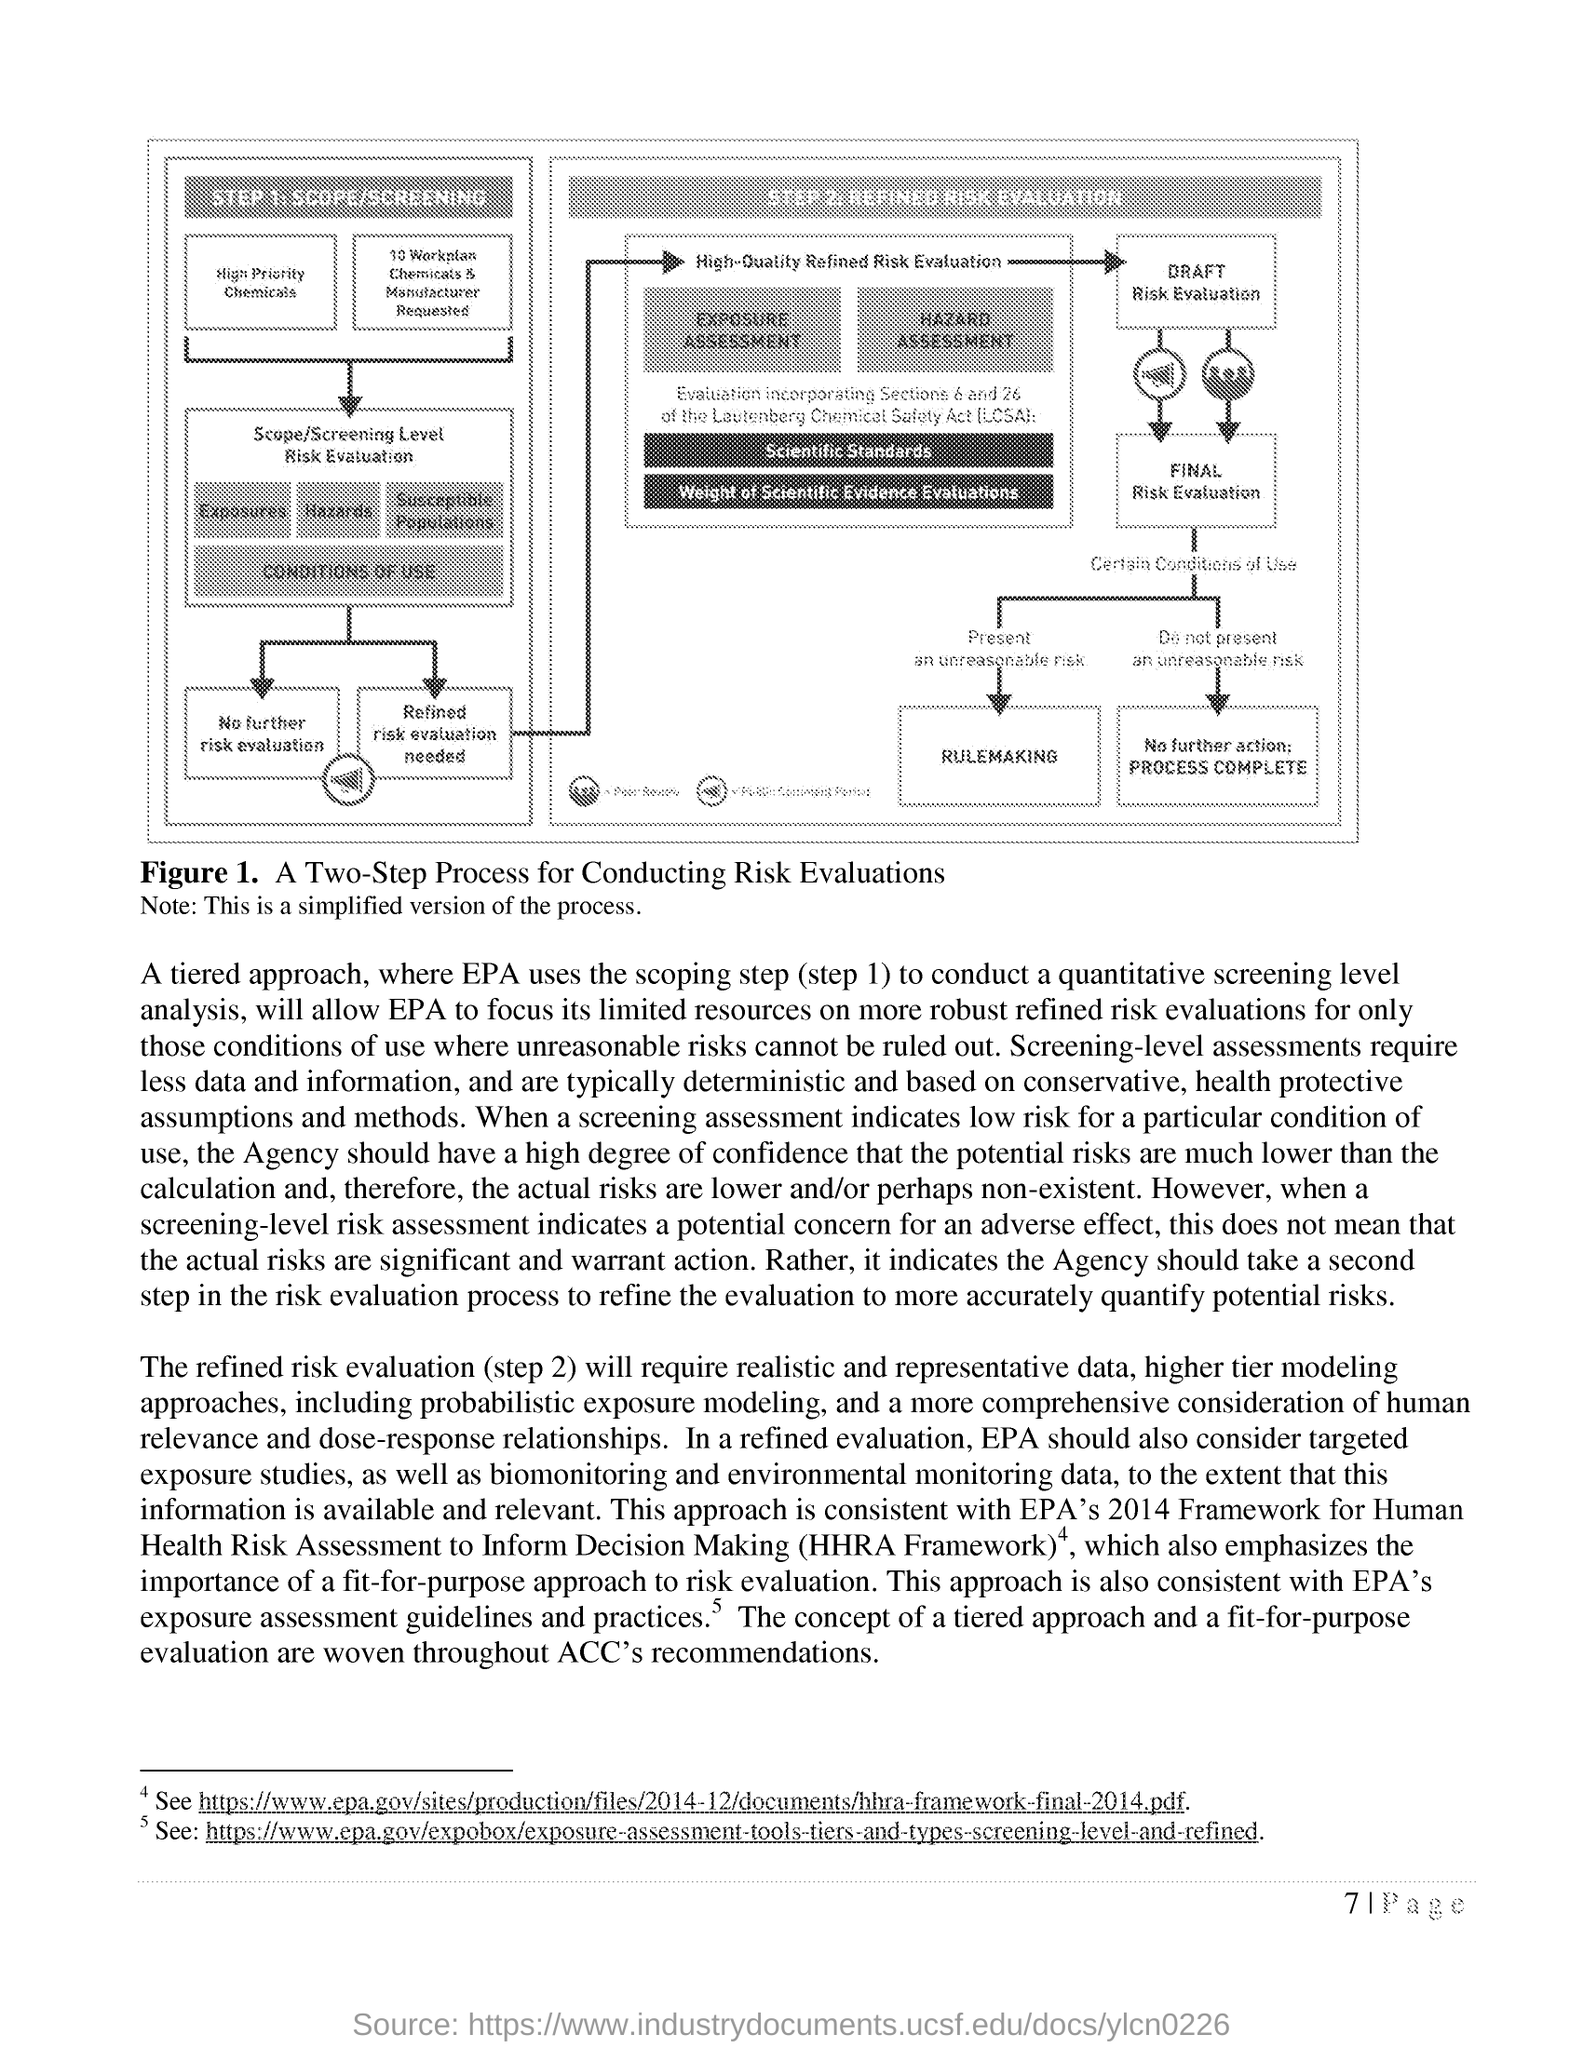Mention a couple of crucial points in this snapshot. This document is located on page 7. The Figure 1 illustrates a two-step process for conducting risk evaluations, which involves identifying and assessing potential risks and implementing risk management strategies to mitigate the identified risks. After presenting an unreasonable risk, the next step in the diagram is rulemaking. Refined Risk Evaluation is the name of STEP 2. 